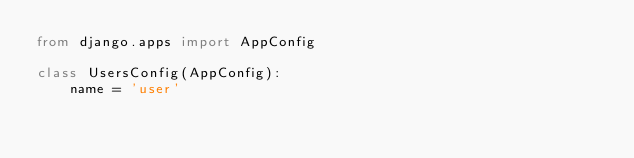<code> <loc_0><loc_0><loc_500><loc_500><_Python_>from django.apps import AppConfig

class UsersConfig(AppConfig):
    name = 'user'
</code> 